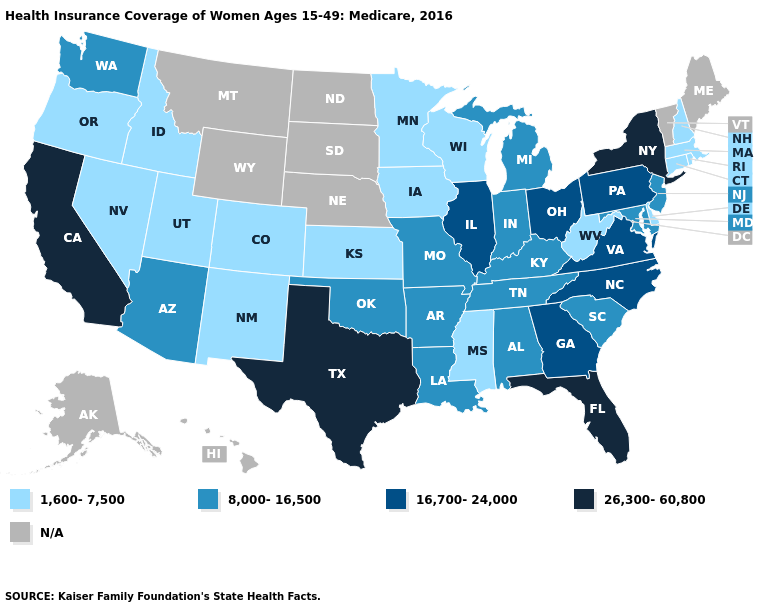Name the states that have a value in the range 26,300-60,800?
Concise answer only. California, Florida, New York, Texas. What is the lowest value in the South?
Write a very short answer. 1,600-7,500. How many symbols are there in the legend?
Give a very brief answer. 5. Name the states that have a value in the range 26,300-60,800?
Give a very brief answer. California, Florida, New York, Texas. What is the value of New Jersey?
Quick response, please. 8,000-16,500. Does the map have missing data?
Write a very short answer. Yes. Name the states that have a value in the range N/A?
Answer briefly. Alaska, Hawaii, Maine, Montana, Nebraska, North Dakota, South Dakota, Vermont, Wyoming. How many symbols are there in the legend?
Keep it brief. 5. What is the highest value in states that border Washington?
Be succinct. 1,600-7,500. What is the value of Oregon?
Short answer required. 1,600-7,500. Which states have the lowest value in the USA?
Quick response, please. Colorado, Connecticut, Delaware, Idaho, Iowa, Kansas, Massachusetts, Minnesota, Mississippi, Nevada, New Hampshire, New Mexico, Oregon, Rhode Island, Utah, West Virginia, Wisconsin. Among the states that border Virginia , which have the highest value?
Be succinct. North Carolina. Name the states that have a value in the range 26,300-60,800?
Be succinct. California, Florida, New York, Texas. Does the first symbol in the legend represent the smallest category?
Keep it brief. Yes. 